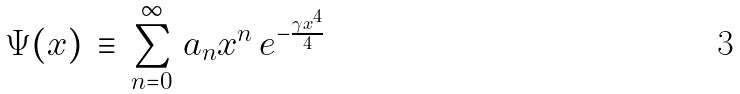Convert formula to latex. <formula><loc_0><loc_0><loc_500><loc_500>\Psi ( x ) \, \equiv \, \sum _ { n = 0 } ^ { \infty } \, a _ { n } x ^ { n } \, e ^ { - \frac { \gamma x ^ { 4 } } 4 }</formula> 